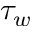Convert formula to latex. <formula><loc_0><loc_0><loc_500><loc_500>\tau _ { w }</formula> 